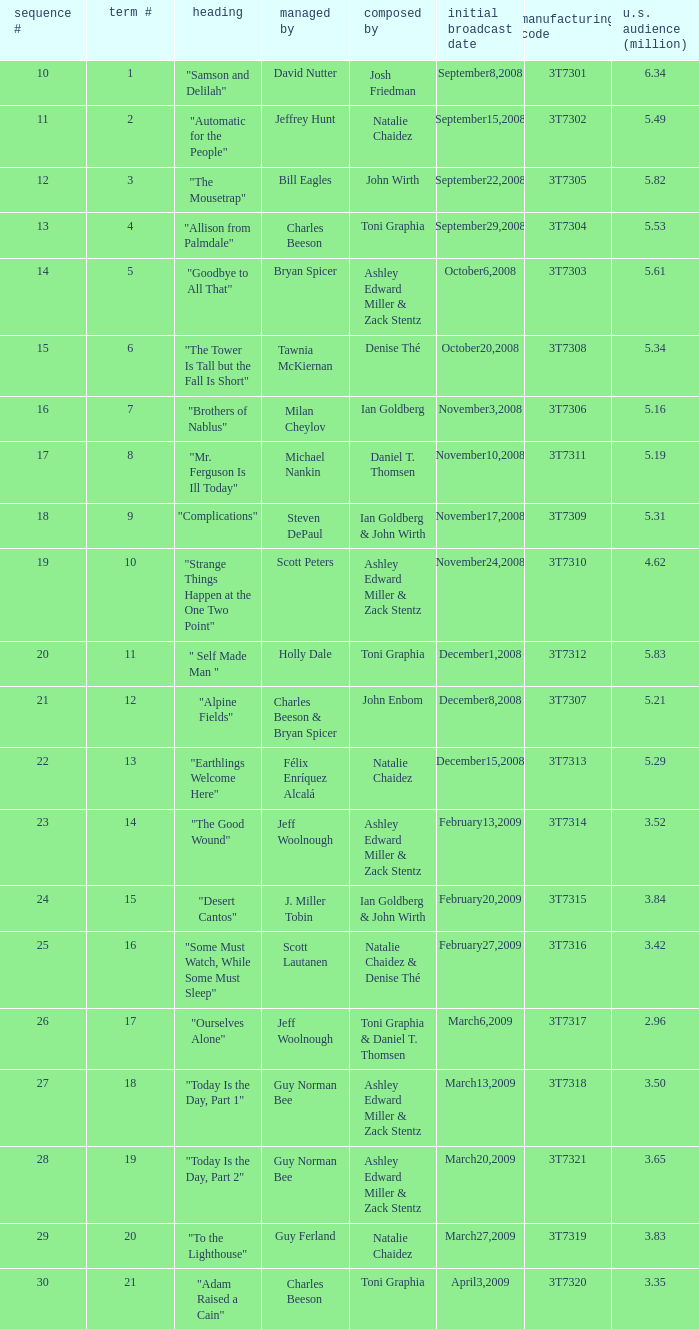Which episode number drew in 3.84 million viewers in the U.S.? 24.0. 